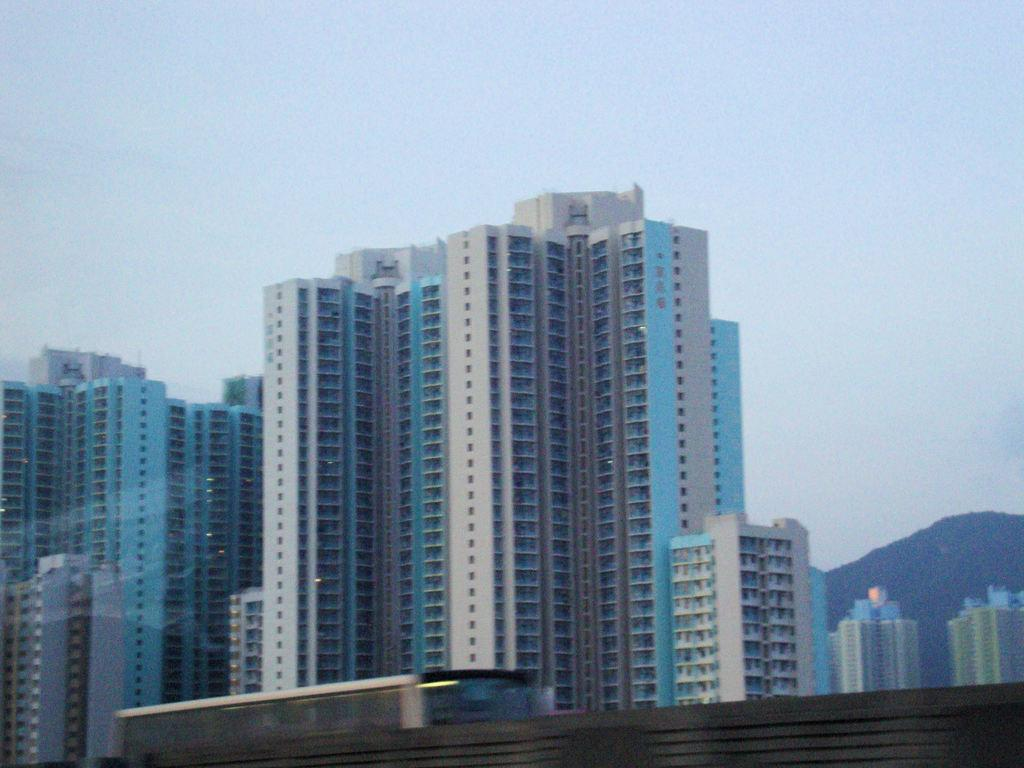What type of structures can be seen in the image? There are buildings in the image. What connects the two sides of the water in the image? There is a bridge in the image. What is on the bridge in the image? A vehicle is present on the bridge. What natural feature can be seen in the background of the image? There is a mountain visible in the background of the image. What else is visible in the background of the image? The sky is visible in the background of the image. What type of calculator is being used by the mice in the image? There are no mice or calculators present in the image. What is the purpose of the protest taking place in the image? There is no protest present in the image. 